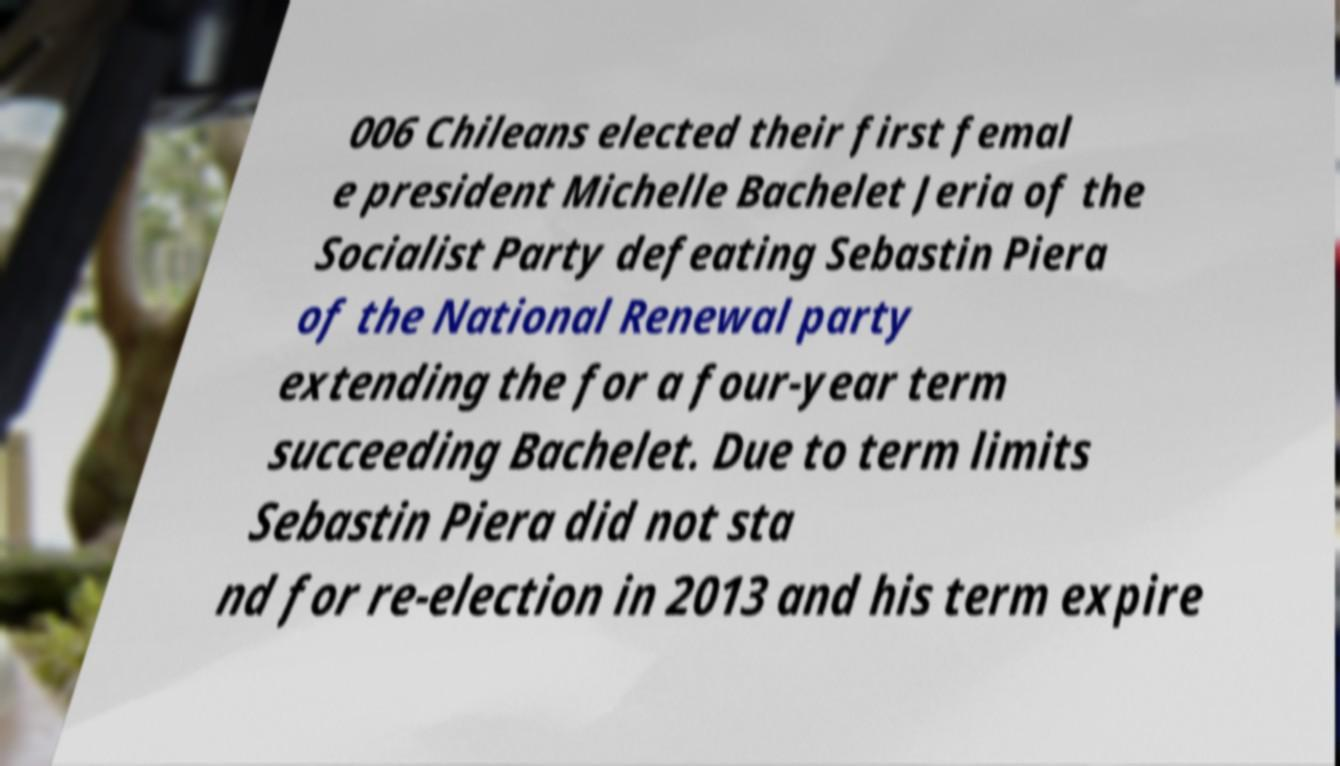Please identify and transcribe the text found in this image. 006 Chileans elected their first femal e president Michelle Bachelet Jeria of the Socialist Party defeating Sebastin Piera of the National Renewal party extending the for a four-year term succeeding Bachelet. Due to term limits Sebastin Piera did not sta nd for re-election in 2013 and his term expire 